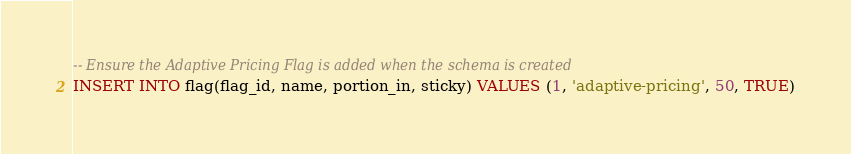Convert code to text. <code><loc_0><loc_0><loc_500><loc_500><_SQL_>-- Ensure the Adaptive Pricing Flag is added when the schema is created
INSERT INTO flag(flag_id, name, portion_in, sticky) VALUES (1, 'adaptive-pricing', 50, TRUE)
</code> 